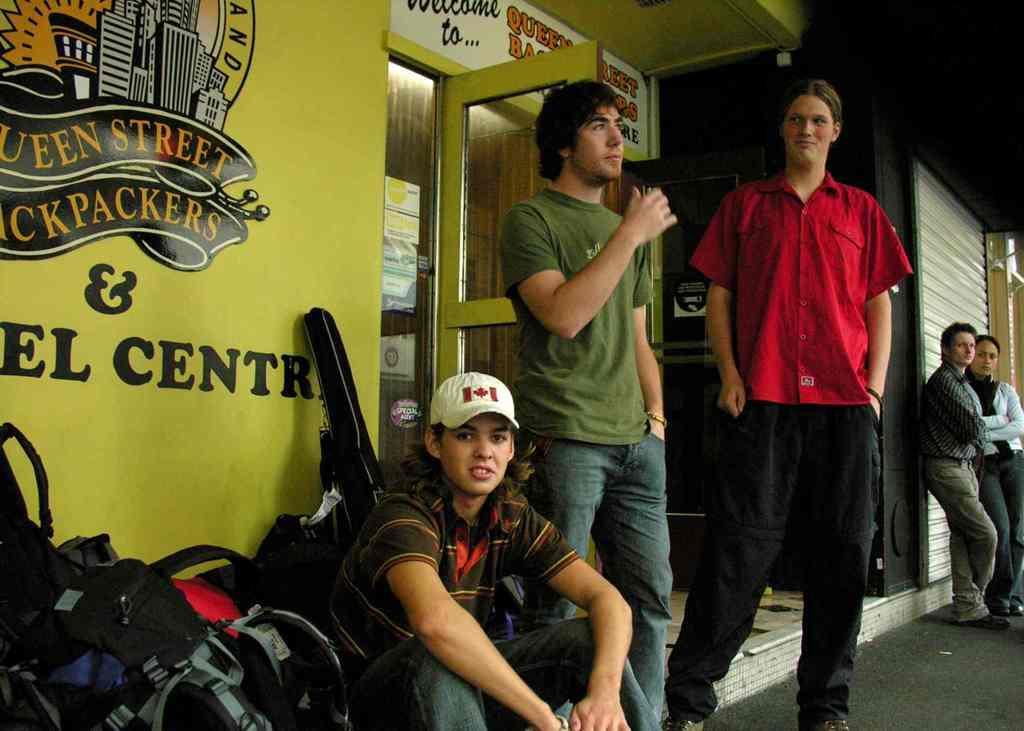Could you give a brief overview of what you see in this image? In this picture we can see few persons, one of them with white cap is sitting, beside to him there are some bags, behind him there is a guitar bag, we can see a wall with some texts and drawings on it, we can see a shutter closed, and some posters on the wall. 